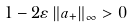Convert formula to latex. <formula><loc_0><loc_0><loc_500><loc_500>1 - 2 \varepsilon \left \| a _ { + } \right \| _ { \infty } > 0</formula> 